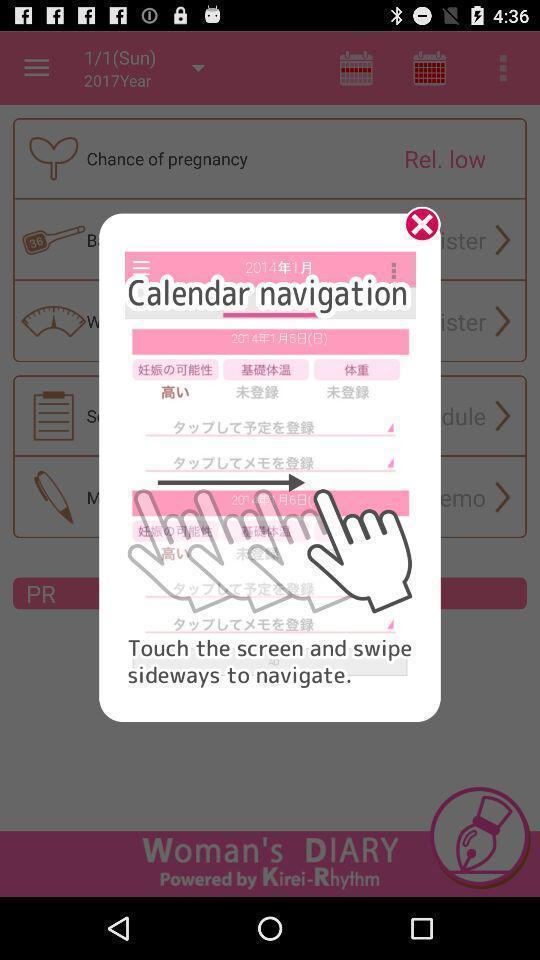Describe the content in this image. Pop up showing calendar navigation. 